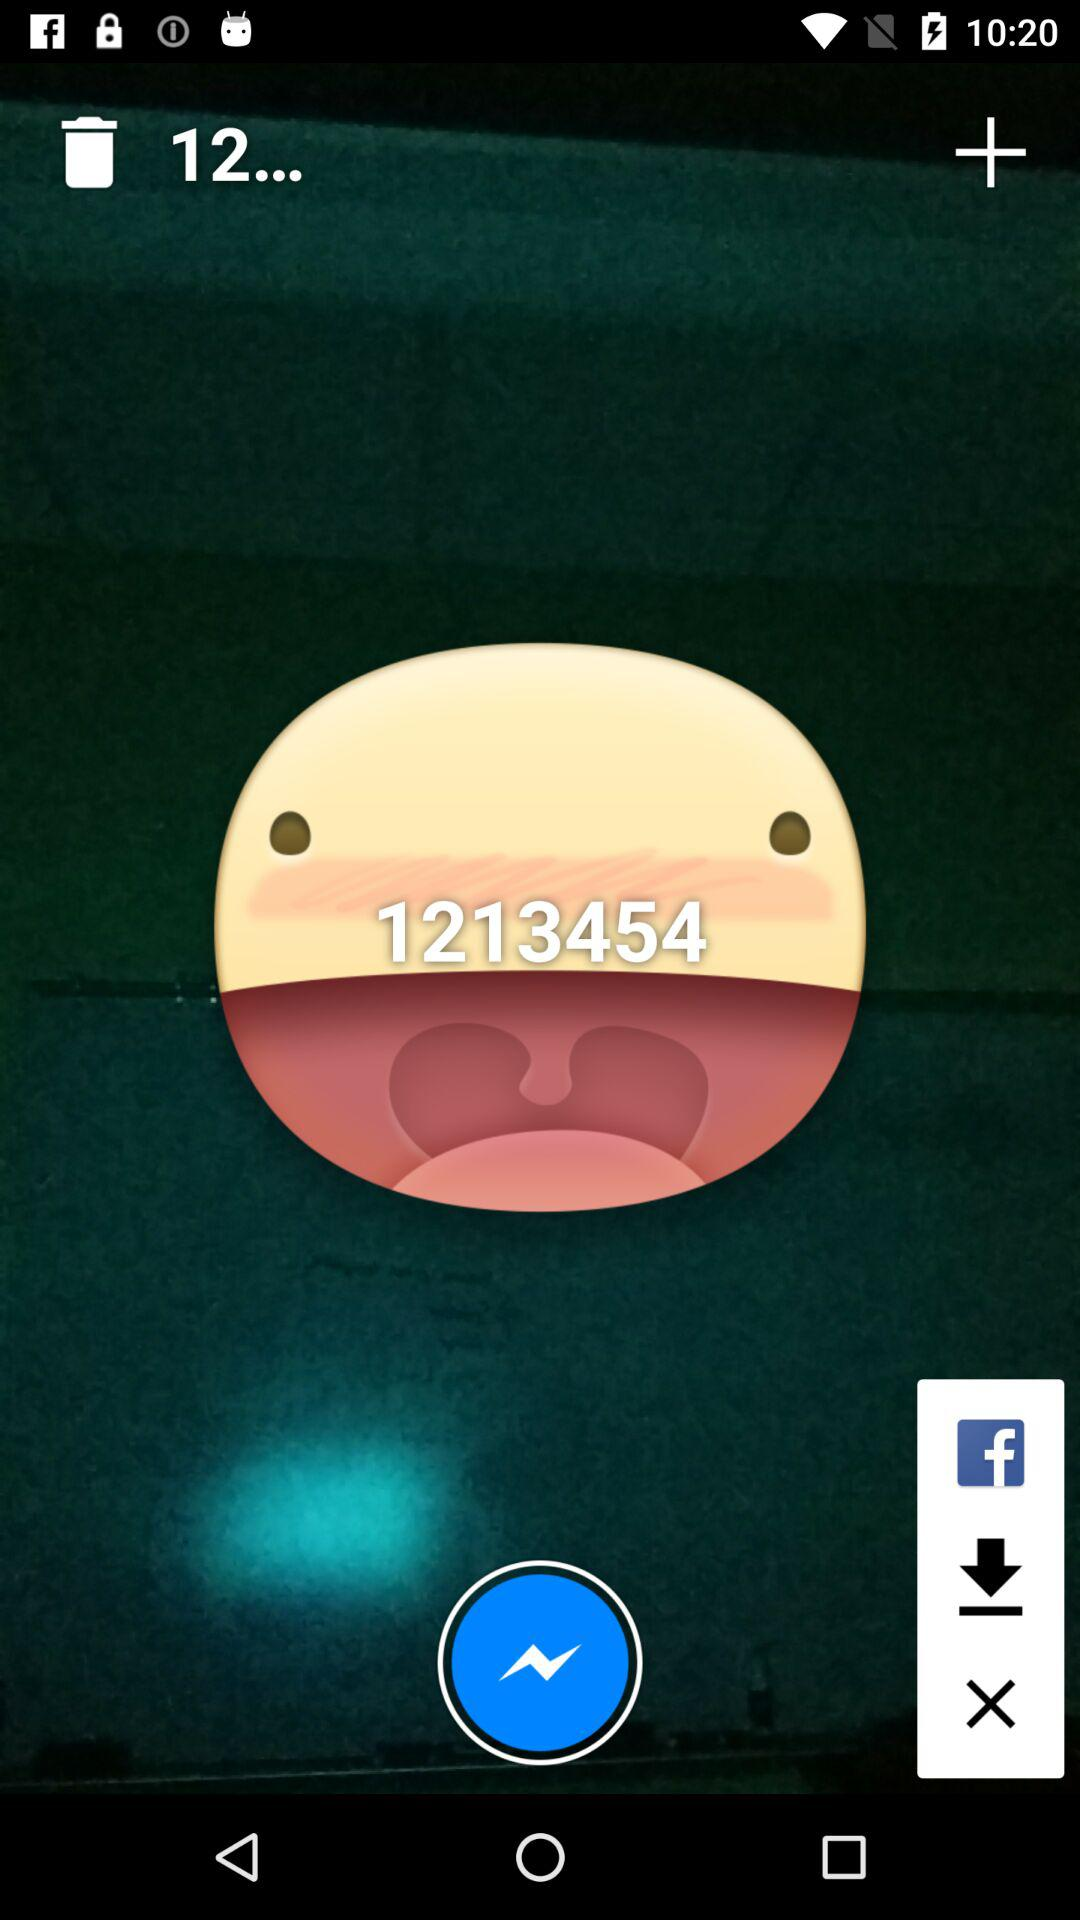How many downloads are there?
When the provided information is insufficient, respond with <no answer>. <no answer> 